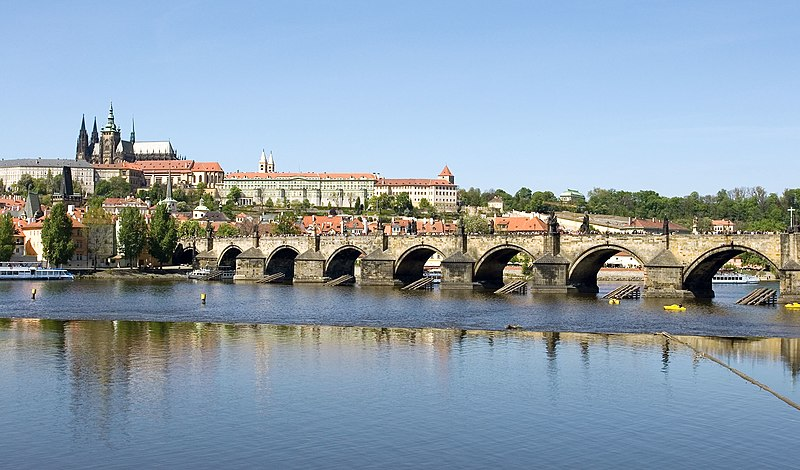Can you describe the main features of this image for me? The image showcases the iconic Charles Bridge stretching across the serene Vltava River in Prague, a city renowned for its enchanting beauty and historical depth. This Gothic bridge, dating back to the 14th century, is a testament to medieval engineering, with its robust stone architecture and continuous line of sculptures that add a layer of grandeur and artistry. Each statue has its own story, steeped in lore and legend, often tied to the saints and patrons of the city. Nestled against a clear azure sky, the bridge creates a stunning reflection on the river's glassy surface, reminiscent of an oil painting. Looking beyond the bridge, you'll notice the striking Prague Castle perched atop the hill, a symbol of Czech statehood, along with a tapestry of historic buildings featuring their characteristic red-tiled roofs. This panoramic view captures not just a bridge, but a gateway to the rich cultural tapestry of Prague. 